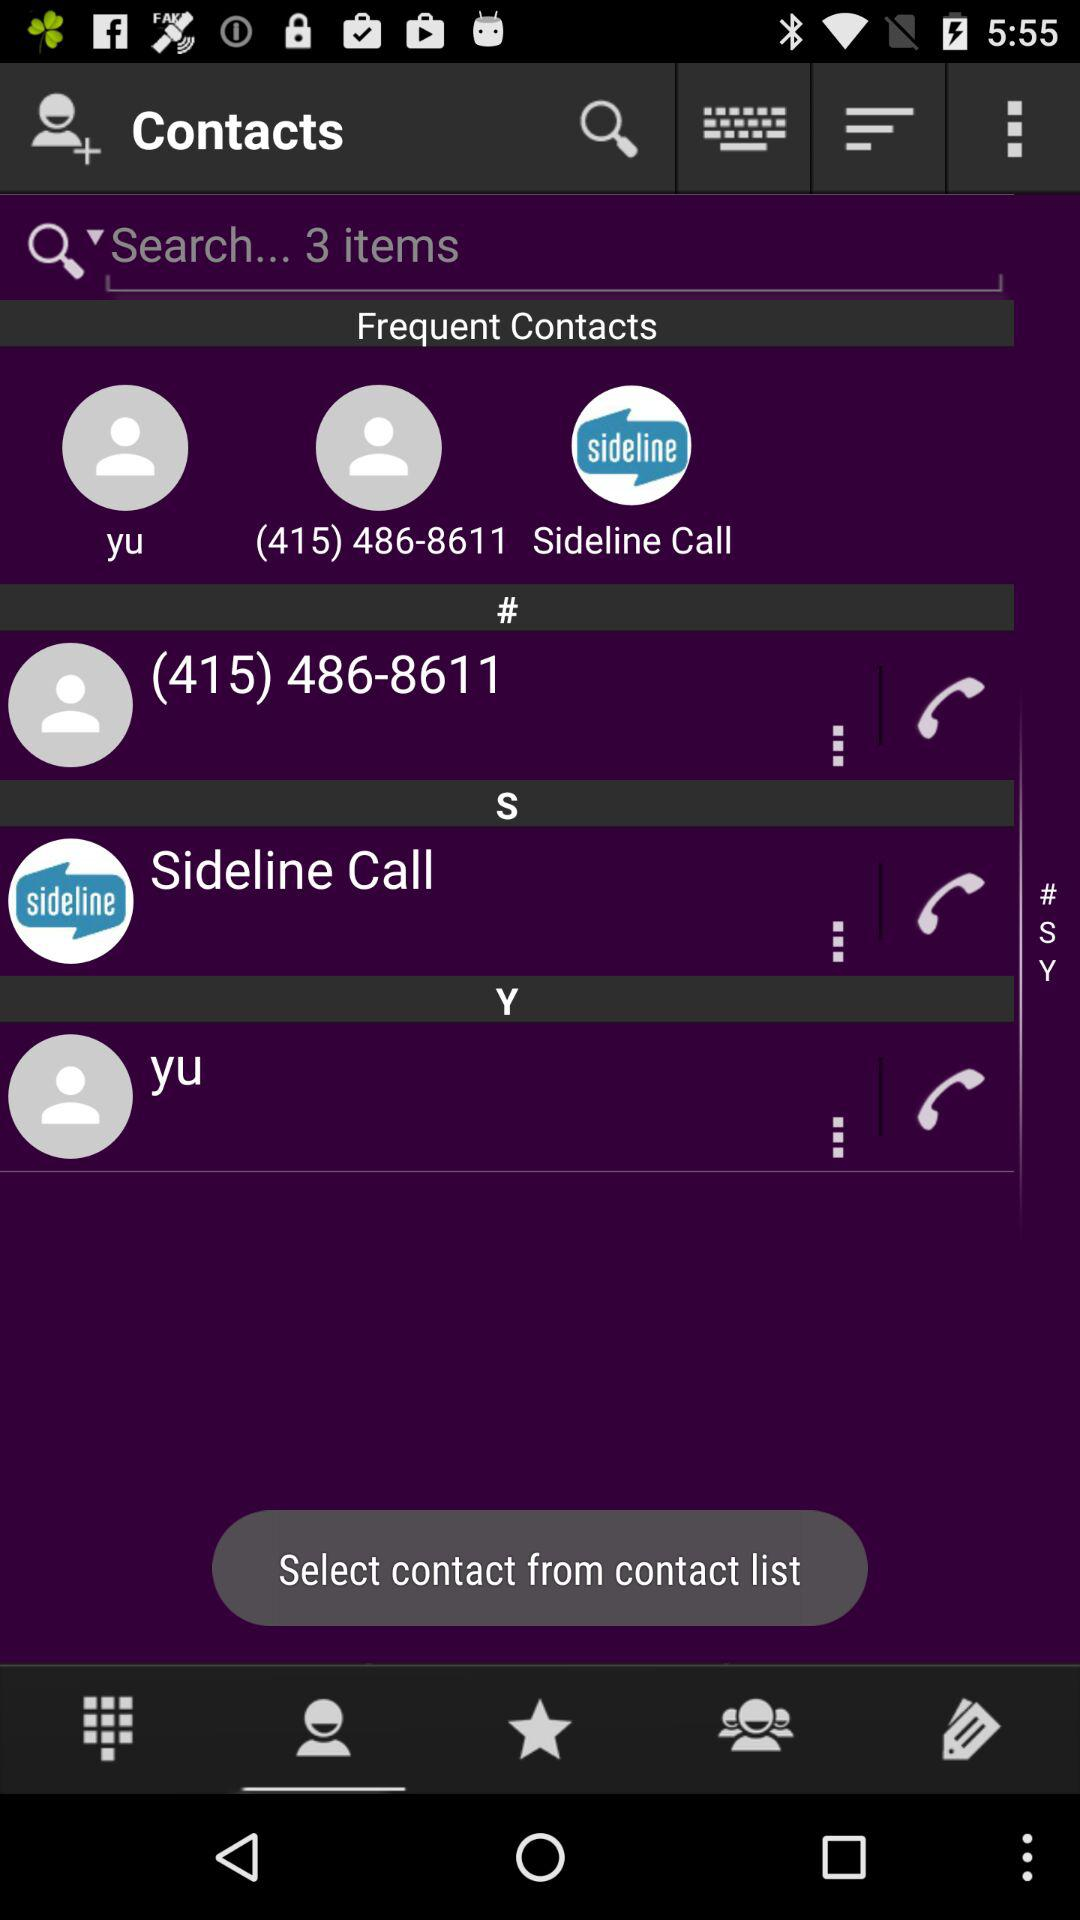Which is the selected tab? The selected tab is "contact". 